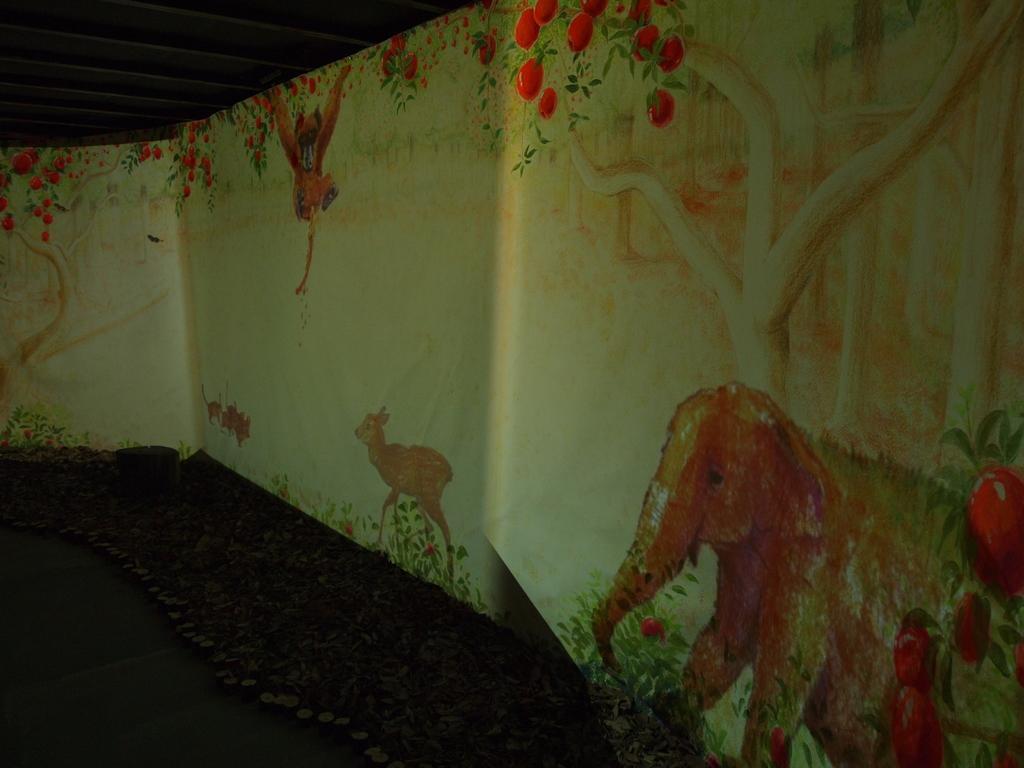Describe this image in one or two sentences. The picture is clicked inside a room. On the wall there are paintings of trees and animals. On the top there is roof. 